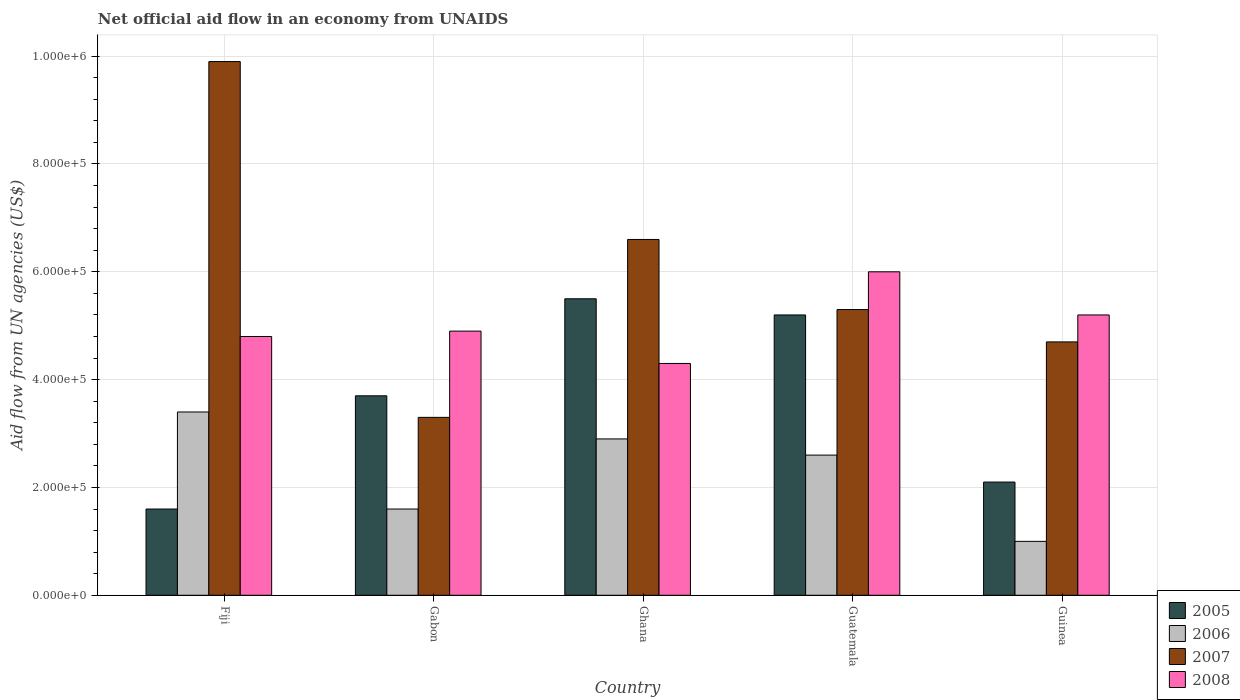How many groups of bars are there?
Your response must be concise. 5. How many bars are there on the 2nd tick from the right?
Provide a succinct answer. 4. What is the label of the 2nd group of bars from the left?
Offer a terse response. Gabon. Across all countries, what is the maximum net official aid flow in 2007?
Provide a short and direct response. 9.90e+05. Across all countries, what is the minimum net official aid flow in 2005?
Your response must be concise. 1.60e+05. In which country was the net official aid flow in 2006 maximum?
Your response must be concise. Fiji. In which country was the net official aid flow in 2007 minimum?
Make the answer very short. Gabon. What is the total net official aid flow in 2006 in the graph?
Your answer should be very brief. 1.15e+06. What is the difference between the net official aid flow in 2006 in Gabon and that in Guatemala?
Offer a very short reply. -1.00e+05. What is the difference between the net official aid flow in 2007 in Gabon and the net official aid flow in 2006 in Ghana?
Give a very brief answer. 4.00e+04. What is the average net official aid flow in 2008 per country?
Offer a very short reply. 5.04e+05. What is the difference between the net official aid flow of/in 2006 and net official aid flow of/in 2007 in Guinea?
Your answer should be compact. -3.70e+05. What is the ratio of the net official aid flow in 2005 in Ghana to that in Guinea?
Make the answer very short. 2.62. What is the difference between the highest and the lowest net official aid flow in 2005?
Your answer should be compact. 3.90e+05. What does the 1st bar from the left in Ghana represents?
Keep it short and to the point. 2005. Is it the case that in every country, the sum of the net official aid flow in 2006 and net official aid flow in 2008 is greater than the net official aid flow in 2005?
Offer a very short reply. Yes. Are all the bars in the graph horizontal?
Your answer should be very brief. No. How many countries are there in the graph?
Your answer should be compact. 5. What is the difference between two consecutive major ticks on the Y-axis?
Offer a terse response. 2.00e+05. Does the graph contain any zero values?
Offer a terse response. No. Does the graph contain grids?
Provide a succinct answer. Yes. Where does the legend appear in the graph?
Offer a terse response. Bottom right. How are the legend labels stacked?
Give a very brief answer. Vertical. What is the title of the graph?
Your answer should be compact. Net official aid flow in an economy from UNAIDS. Does "1963" appear as one of the legend labels in the graph?
Provide a succinct answer. No. What is the label or title of the Y-axis?
Give a very brief answer. Aid flow from UN agencies (US$). What is the Aid flow from UN agencies (US$) in 2005 in Fiji?
Your answer should be very brief. 1.60e+05. What is the Aid flow from UN agencies (US$) in 2007 in Fiji?
Offer a very short reply. 9.90e+05. What is the Aid flow from UN agencies (US$) in 2005 in Gabon?
Your response must be concise. 3.70e+05. What is the Aid flow from UN agencies (US$) in 2006 in Gabon?
Your response must be concise. 1.60e+05. What is the Aid flow from UN agencies (US$) in 2007 in Gabon?
Provide a short and direct response. 3.30e+05. What is the Aid flow from UN agencies (US$) in 2008 in Gabon?
Offer a terse response. 4.90e+05. What is the Aid flow from UN agencies (US$) of 2008 in Ghana?
Make the answer very short. 4.30e+05. What is the Aid flow from UN agencies (US$) in 2005 in Guatemala?
Your response must be concise. 5.20e+05. What is the Aid flow from UN agencies (US$) of 2007 in Guatemala?
Offer a terse response. 5.30e+05. What is the Aid flow from UN agencies (US$) of 2008 in Guatemala?
Your answer should be compact. 6.00e+05. What is the Aid flow from UN agencies (US$) of 2006 in Guinea?
Provide a succinct answer. 1.00e+05. What is the Aid flow from UN agencies (US$) in 2007 in Guinea?
Your answer should be very brief. 4.70e+05. What is the Aid flow from UN agencies (US$) of 2008 in Guinea?
Ensure brevity in your answer.  5.20e+05. Across all countries, what is the maximum Aid flow from UN agencies (US$) in 2007?
Provide a succinct answer. 9.90e+05. Across all countries, what is the minimum Aid flow from UN agencies (US$) in 2007?
Offer a terse response. 3.30e+05. Across all countries, what is the minimum Aid flow from UN agencies (US$) in 2008?
Offer a terse response. 4.30e+05. What is the total Aid flow from UN agencies (US$) in 2005 in the graph?
Offer a very short reply. 1.81e+06. What is the total Aid flow from UN agencies (US$) of 2006 in the graph?
Your answer should be very brief. 1.15e+06. What is the total Aid flow from UN agencies (US$) of 2007 in the graph?
Give a very brief answer. 2.98e+06. What is the total Aid flow from UN agencies (US$) in 2008 in the graph?
Offer a terse response. 2.52e+06. What is the difference between the Aid flow from UN agencies (US$) in 2007 in Fiji and that in Gabon?
Your answer should be compact. 6.60e+05. What is the difference between the Aid flow from UN agencies (US$) in 2005 in Fiji and that in Ghana?
Provide a short and direct response. -3.90e+05. What is the difference between the Aid flow from UN agencies (US$) in 2006 in Fiji and that in Ghana?
Your answer should be very brief. 5.00e+04. What is the difference between the Aid flow from UN agencies (US$) in 2007 in Fiji and that in Ghana?
Keep it short and to the point. 3.30e+05. What is the difference between the Aid flow from UN agencies (US$) in 2008 in Fiji and that in Ghana?
Keep it short and to the point. 5.00e+04. What is the difference between the Aid flow from UN agencies (US$) of 2005 in Fiji and that in Guatemala?
Make the answer very short. -3.60e+05. What is the difference between the Aid flow from UN agencies (US$) in 2006 in Fiji and that in Guatemala?
Ensure brevity in your answer.  8.00e+04. What is the difference between the Aid flow from UN agencies (US$) in 2007 in Fiji and that in Guatemala?
Your response must be concise. 4.60e+05. What is the difference between the Aid flow from UN agencies (US$) in 2008 in Fiji and that in Guatemala?
Offer a very short reply. -1.20e+05. What is the difference between the Aid flow from UN agencies (US$) in 2007 in Fiji and that in Guinea?
Keep it short and to the point. 5.20e+05. What is the difference between the Aid flow from UN agencies (US$) of 2005 in Gabon and that in Ghana?
Give a very brief answer. -1.80e+05. What is the difference between the Aid flow from UN agencies (US$) of 2007 in Gabon and that in Ghana?
Your response must be concise. -3.30e+05. What is the difference between the Aid flow from UN agencies (US$) in 2008 in Gabon and that in Ghana?
Provide a short and direct response. 6.00e+04. What is the difference between the Aid flow from UN agencies (US$) in 2006 in Gabon and that in Guinea?
Provide a succinct answer. 6.00e+04. What is the difference between the Aid flow from UN agencies (US$) of 2005 in Ghana and that in Guatemala?
Your answer should be compact. 3.00e+04. What is the difference between the Aid flow from UN agencies (US$) of 2007 in Ghana and that in Guatemala?
Your answer should be very brief. 1.30e+05. What is the difference between the Aid flow from UN agencies (US$) in 2007 in Ghana and that in Guinea?
Your answer should be very brief. 1.90e+05. What is the difference between the Aid flow from UN agencies (US$) of 2005 in Guatemala and that in Guinea?
Your answer should be very brief. 3.10e+05. What is the difference between the Aid flow from UN agencies (US$) of 2006 in Guatemala and that in Guinea?
Your answer should be very brief. 1.60e+05. What is the difference between the Aid flow from UN agencies (US$) in 2008 in Guatemala and that in Guinea?
Your answer should be very brief. 8.00e+04. What is the difference between the Aid flow from UN agencies (US$) in 2005 in Fiji and the Aid flow from UN agencies (US$) in 2008 in Gabon?
Provide a short and direct response. -3.30e+05. What is the difference between the Aid flow from UN agencies (US$) of 2005 in Fiji and the Aid flow from UN agencies (US$) of 2006 in Ghana?
Provide a succinct answer. -1.30e+05. What is the difference between the Aid flow from UN agencies (US$) in 2005 in Fiji and the Aid flow from UN agencies (US$) in 2007 in Ghana?
Offer a very short reply. -5.00e+05. What is the difference between the Aid flow from UN agencies (US$) in 2006 in Fiji and the Aid flow from UN agencies (US$) in 2007 in Ghana?
Give a very brief answer. -3.20e+05. What is the difference between the Aid flow from UN agencies (US$) in 2006 in Fiji and the Aid flow from UN agencies (US$) in 2008 in Ghana?
Your response must be concise. -9.00e+04. What is the difference between the Aid flow from UN agencies (US$) in 2007 in Fiji and the Aid flow from UN agencies (US$) in 2008 in Ghana?
Keep it short and to the point. 5.60e+05. What is the difference between the Aid flow from UN agencies (US$) of 2005 in Fiji and the Aid flow from UN agencies (US$) of 2006 in Guatemala?
Your answer should be very brief. -1.00e+05. What is the difference between the Aid flow from UN agencies (US$) in 2005 in Fiji and the Aid flow from UN agencies (US$) in 2007 in Guatemala?
Your answer should be very brief. -3.70e+05. What is the difference between the Aid flow from UN agencies (US$) of 2005 in Fiji and the Aid flow from UN agencies (US$) of 2008 in Guatemala?
Your answer should be very brief. -4.40e+05. What is the difference between the Aid flow from UN agencies (US$) of 2006 in Fiji and the Aid flow from UN agencies (US$) of 2007 in Guatemala?
Offer a very short reply. -1.90e+05. What is the difference between the Aid flow from UN agencies (US$) of 2006 in Fiji and the Aid flow from UN agencies (US$) of 2008 in Guatemala?
Keep it short and to the point. -2.60e+05. What is the difference between the Aid flow from UN agencies (US$) in 2005 in Fiji and the Aid flow from UN agencies (US$) in 2006 in Guinea?
Your answer should be compact. 6.00e+04. What is the difference between the Aid flow from UN agencies (US$) of 2005 in Fiji and the Aid flow from UN agencies (US$) of 2007 in Guinea?
Keep it short and to the point. -3.10e+05. What is the difference between the Aid flow from UN agencies (US$) of 2005 in Fiji and the Aid flow from UN agencies (US$) of 2008 in Guinea?
Provide a short and direct response. -3.60e+05. What is the difference between the Aid flow from UN agencies (US$) of 2007 in Fiji and the Aid flow from UN agencies (US$) of 2008 in Guinea?
Keep it short and to the point. 4.70e+05. What is the difference between the Aid flow from UN agencies (US$) of 2005 in Gabon and the Aid flow from UN agencies (US$) of 2006 in Ghana?
Provide a short and direct response. 8.00e+04. What is the difference between the Aid flow from UN agencies (US$) in 2005 in Gabon and the Aid flow from UN agencies (US$) in 2008 in Ghana?
Offer a terse response. -6.00e+04. What is the difference between the Aid flow from UN agencies (US$) of 2006 in Gabon and the Aid flow from UN agencies (US$) of 2007 in Ghana?
Give a very brief answer. -5.00e+05. What is the difference between the Aid flow from UN agencies (US$) of 2006 in Gabon and the Aid flow from UN agencies (US$) of 2008 in Ghana?
Give a very brief answer. -2.70e+05. What is the difference between the Aid flow from UN agencies (US$) in 2007 in Gabon and the Aid flow from UN agencies (US$) in 2008 in Ghana?
Make the answer very short. -1.00e+05. What is the difference between the Aid flow from UN agencies (US$) in 2005 in Gabon and the Aid flow from UN agencies (US$) in 2006 in Guatemala?
Keep it short and to the point. 1.10e+05. What is the difference between the Aid flow from UN agencies (US$) in 2006 in Gabon and the Aid flow from UN agencies (US$) in 2007 in Guatemala?
Your response must be concise. -3.70e+05. What is the difference between the Aid flow from UN agencies (US$) in 2006 in Gabon and the Aid flow from UN agencies (US$) in 2008 in Guatemala?
Offer a terse response. -4.40e+05. What is the difference between the Aid flow from UN agencies (US$) in 2007 in Gabon and the Aid flow from UN agencies (US$) in 2008 in Guatemala?
Ensure brevity in your answer.  -2.70e+05. What is the difference between the Aid flow from UN agencies (US$) of 2005 in Gabon and the Aid flow from UN agencies (US$) of 2007 in Guinea?
Your answer should be compact. -1.00e+05. What is the difference between the Aid flow from UN agencies (US$) of 2005 in Gabon and the Aid flow from UN agencies (US$) of 2008 in Guinea?
Make the answer very short. -1.50e+05. What is the difference between the Aid flow from UN agencies (US$) in 2006 in Gabon and the Aid flow from UN agencies (US$) in 2007 in Guinea?
Make the answer very short. -3.10e+05. What is the difference between the Aid flow from UN agencies (US$) in 2006 in Gabon and the Aid flow from UN agencies (US$) in 2008 in Guinea?
Give a very brief answer. -3.60e+05. What is the difference between the Aid flow from UN agencies (US$) of 2007 in Gabon and the Aid flow from UN agencies (US$) of 2008 in Guinea?
Your response must be concise. -1.90e+05. What is the difference between the Aid flow from UN agencies (US$) in 2005 in Ghana and the Aid flow from UN agencies (US$) in 2006 in Guatemala?
Offer a terse response. 2.90e+05. What is the difference between the Aid flow from UN agencies (US$) of 2006 in Ghana and the Aid flow from UN agencies (US$) of 2007 in Guatemala?
Offer a very short reply. -2.40e+05. What is the difference between the Aid flow from UN agencies (US$) of 2006 in Ghana and the Aid flow from UN agencies (US$) of 2008 in Guatemala?
Give a very brief answer. -3.10e+05. What is the difference between the Aid flow from UN agencies (US$) of 2005 in Ghana and the Aid flow from UN agencies (US$) of 2006 in Guinea?
Ensure brevity in your answer.  4.50e+05. What is the difference between the Aid flow from UN agencies (US$) of 2005 in Ghana and the Aid flow from UN agencies (US$) of 2008 in Guinea?
Offer a very short reply. 3.00e+04. What is the difference between the Aid flow from UN agencies (US$) of 2006 in Ghana and the Aid flow from UN agencies (US$) of 2007 in Guinea?
Provide a succinct answer. -1.80e+05. What is the difference between the Aid flow from UN agencies (US$) in 2005 in Guatemala and the Aid flow from UN agencies (US$) in 2007 in Guinea?
Give a very brief answer. 5.00e+04. What is the difference between the Aid flow from UN agencies (US$) in 2006 in Guatemala and the Aid flow from UN agencies (US$) in 2007 in Guinea?
Provide a succinct answer. -2.10e+05. What is the average Aid flow from UN agencies (US$) in 2005 per country?
Your response must be concise. 3.62e+05. What is the average Aid flow from UN agencies (US$) of 2006 per country?
Your response must be concise. 2.30e+05. What is the average Aid flow from UN agencies (US$) of 2007 per country?
Give a very brief answer. 5.96e+05. What is the average Aid flow from UN agencies (US$) of 2008 per country?
Your answer should be compact. 5.04e+05. What is the difference between the Aid flow from UN agencies (US$) in 2005 and Aid flow from UN agencies (US$) in 2006 in Fiji?
Ensure brevity in your answer.  -1.80e+05. What is the difference between the Aid flow from UN agencies (US$) in 2005 and Aid flow from UN agencies (US$) in 2007 in Fiji?
Give a very brief answer. -8.30e+05. What is the difference between the Aid flow from UN agencies (US$) of 2005 and Aid flow from UN agencies (US$) of 2008 in Fiji?
Make the answer very short. -3.20e+05. What is the difference between the Aid flow from UN agencies (US$) of 2006 and Aid flow from UN agencies (US$) of 2007 in Fiji?
Your answer should be compact. -6.50e+05. What is the difference between the Aid flow from UN agencies (US$) in 2007 and Aid flow from UN agencies (US$) in 2008 in Fiji?
Give a very brief answer. 5.10e+05. What is the difference between the Aid flow from UN agencies (US$) in 2005 and Aid flow from UN agencies (US$) in 2007 in Gabon?
Provide a short and direct response. 4.00e+04. What is the difference between the Aid flow from UN agencies (US$) of 2005 and Aid flow from UN agencies (US$) of 2008 in Gabon?
Keep it short and to the point. -1.20e+05. What is the difference between the Aid flow from UN agencies (US$) in 2006 and Aid flow from UN agencies (US$) in 2007 in Gabon?
Provide a succinct answer. -1.70e+05. What is the difference between the Aid flow from UN agencies (US$) of 2006 and Aid flow from UN agencies (US$) of 2008 in Gabon?
Your answer should be very brief. -3.30e+05. What is the difference between the Aid flow from UN agencies (US$) of 2005 and Aid flow from UN agencies (US$) of 2006 in Ghana?
Make the answer very short. 2.60e+05. What is the difference between the Aid flow from UN agencies (US$) of 2005 and Aid flow from UN agencies (US$) of 2008 in Ghana?
Your answer should be very brief. 1.20e+05. What is the difference between the Aid flow from UN agencies (US$) in 2006 and Aid flow from UN agencies (US$) in 2007 in Ghana?
Keep it short and to the point. -3.70e+05. What is the difference between the Aid flow from UN agencies (US$) of 2006 and Aid flow from UN agencies (US$) of 2008 in Ghana?
Your answer should be very brief. -1.40e+05. What is the difference between the Aid flow from UN agencies (US$) in 2005 and Aid flow from UN agencies (US$) in 2007 in Guatemala?
Your answer should be very brief. -10000. What is the difference between the Aid flow from UN agencies (US$) in 2007 and Aid flow from UN agencies (US$) in 2008 in Guatemala?
Keep it short and to the point. -7.00e+04. What is the difference between the Aid flow from UN agencies (US$) of 2005 and Aid flow from UN agencies (US$) of 2007 in Guinea?
Offer a very short reply. -2.60e+05. What is the difference between the Aid flow from UN agencies (US$) in 2005 and Aid flow from UN agencies (US$) in 2008 in Guinea?
Provide a succinct answer. -3.10e+05. What is the difference between the Aid flow from UN agencies (US$) of 2006 and Aid flow from UN agencies (US$) of 2007 in Guinea?
Provide a succinct answer. -3.70e+05. What is the difference between the Aid flow from UN agencies (US$) of 2006 and Aid flow from UN agencies (US$) of 2008 in Guinea?
Give a very brief answer. -4.20e+05. What is the difference between the Aid flow from UN agencies (US$) of 2007 and Aid flow from UN agencies (US$) of 2008 in Guinea?
Provide a succinct answer. -5.00e+04. What is the ratio of the Aid flow from UN agencies (US$) in 2005 in Fiji to that in Gabon?
Provide a short and direct response. 0.43. What is the ratio of the Aid flow from UN agencies (US$) in 2006 in Fiji to that in Gabon?
Make the answer very short. 2.12. What is the ratio of the Aid flow from UN agencies (US$) of 2008 in Fiji to that in Gabon?
Provide a short and direct response. 0.98. What is the ratio of the Aid flow from UN agencies (US$) in 2005 in Fiji to that in Ghana?
Your answer should be very brief. 0.29. What is the ratio of the Aid flow from UN agencies (US$) of 2006 in Fiji to that in Ghana?
Make the answer very short. 1.17. What is the ratio of the Aid flow from UN agencies (US$) in 2007 in Fiji to that in Ghana?
Provide a succinct answer. 1.5. What is the ratio of the Aid flow from UN agencies (US$) in 2008 in Fiji to that in Ghana?
Provide a short and direct response. 1.12. What is the ratio of the Aid flow from UN agencies (US$) of 2005 in Fiji to that in Guatemala?
Provide a short and direct response. 0.31. What is the ratio of the Aid flow from UN agencies (US$) of 2006 in Fiji to that in Guatemala?
Your answer should be compact. 1.31. What is the ratio of the Aid flow from UN agencies (US$) in 2007 in Fiji to that in Guatemala?
Your answer should be very brief. 1.87. What is the ratio of the Aid flow from UN agencies (US$) of 2008 in Fiji to that in Guatemala?
Your answer should be very brief. 0.8. What is the ratio of the Aid flow from UN agencies (US$) in 2005 in Fiji to that in Guinea?
Ensure brevity in your answer.  0.76. What is the ratio of the Aid flow from UN agencies (US$) in 2007 in Fiji to that in Guinea?
Ensure brevity in your answer.  2.11. What is the ratio of the Aid flow from UN agencies (US$) of 2008 in Fiji to that in Guinea?
Your answer should be very brief. 0.92. What is the ratio of the Aid flow from UN agencies (US$) in 2005 in Gabon to that in Ghana?
Offer a very short reply. 0.67. What is the ratio of the Aid flow from UN agencies (US$) of 2006 in Gabon to that in Ghana?
Provide a short and direct response. 0.55. What is the ratio of the Aid flow from UN agencies (US$) in 2007 in Gabon to that in Ghana?
Your answer should be very brief. 0.5. What is the ratio of the Aid flow from UN agencies (US$) in 2008 in Gabon to that in Ghana?
Your answer should be very brief. 1.14. What is the ratio of the Aid flow from UN agencies (US$) in 2005 in Gabon to that in Guatemala?
Offer a very short reply. 0.71. What is the ratio of the Aid flow from UN agencies (US$) of 2006 in Gabon to that in Guatemala?
Offer a very short reply. 0.62. What is the ratio of the Aid flow from UN agencies (US$) of 2007 in Gabon to that in Guatemala?
Your response must be concise. 0.62. What is the ratio of the Aid flow from UN agencies (US$) of 2008 in Gabon to that in Guatemala?
Offer a terse response. 0.82. What is the ratio of the Aid flow from UN agencies (US$) of 2005 in Gabon to that in Guinea?
Make the answer very short. 1.76. What is the ratio of the Aid flow from UN agencies (US$) of 2007 in Gabon to that in Guinea?
Keep it short and to the point. 0.7. What is the ratio of the Aid flow from UN agencies (US$) of 2008 in Gabon to that in Guinea?
Provide a short and direct response. 0.94. What is the ratio of the Aid flow from UN agencies (US$) in 2005 in Ghana to that in Guatemala?
Offer a very short reply. 1.06. What is the ratio of the Aid flow from UN agencies (US$) of 2006 in Ghana to that in Guatemala?
Your answer should be compact. 1.12. What is the ratio of the Aid flow from UN agencies (US$) of 2007 in Ghana to that in Guatemala?
Offer a very short reply. 1.25. What is the ratio of the Aid flow from UN agencies (US$) of 2008 in Ghana to that in Guatemala?
Provide a succinct answer. 0.72. What is the ratio of the Aid flow from UN agencies (US$) of 2005 in Ghana to that in Guinea?
Your answer should be very brief. 2.62. What is the ratio of the Aid flow from UN agencies (US$) of 2007 in Ghana to that in Guinea?
Offer a very short reply. 1.4. What is the ratio of the Aid flow from UN agencies (US$) in 2008 in Ghana to that in Guinea?
Offer a very short reply. 0.83. What is the ratio of the Aid flow from UN agencies (US$) of 2005 in Guatemala to that in Guinea?
Keep it short and to the point. 2.48. What is the ratio of the Aid flow from UN agencies (US$) in 2007 in Guatemala to that in Guinea?
Give a very brief answer. 1.13. What is the ratio of the Aid flow from UN agencies (US$) of 2008 in Guatemala to that in Guinea?
Your answer should be compact. 1.15. What is the difference between the highest and the second highest Aid flow from UN agencies (US$) in 2005?
Offer a terse response. 3.00e+04. What is the difference between the highest and the second highest Aid flow from UN agencies (US$) in 2006?
Your response must be concise. 5.00e+04. What is the difference between the highest and the second highest Aid flow from UN agencies (US$) in 2008?
Your response must be concise. 8.00e+04. What is the difference between the highest and the lowest Aid flow from UN agencies (US$) of 2005?
Your answer should be compact. 3.90e+05. What is the difference between the highest and the lowest Aid flow from UN agencies (US$) in 2007?
Provide a succinct answer. 6.60e+05. 